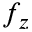Convert formula to latex. <formula><loc_0><loc_0><loc_500><loc_500>f _ { z }</formula> 